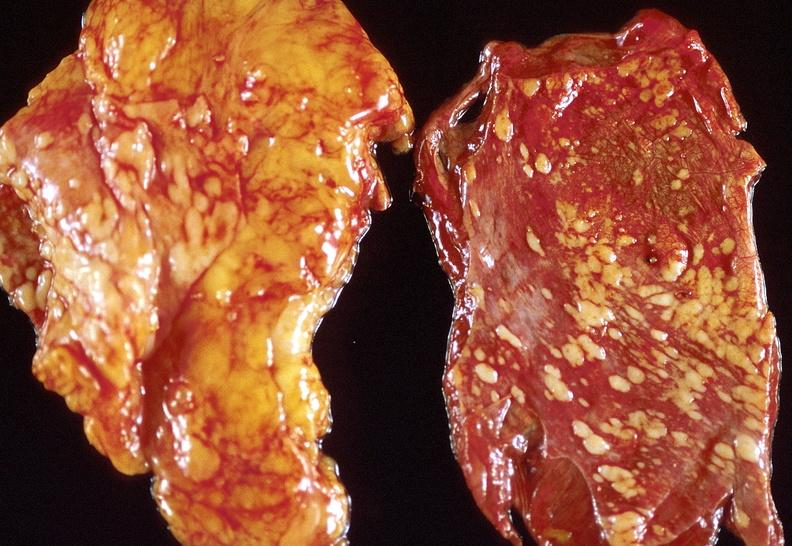does this image show lung carcinoma?
Answer the question using a single word or phrase. Yes 